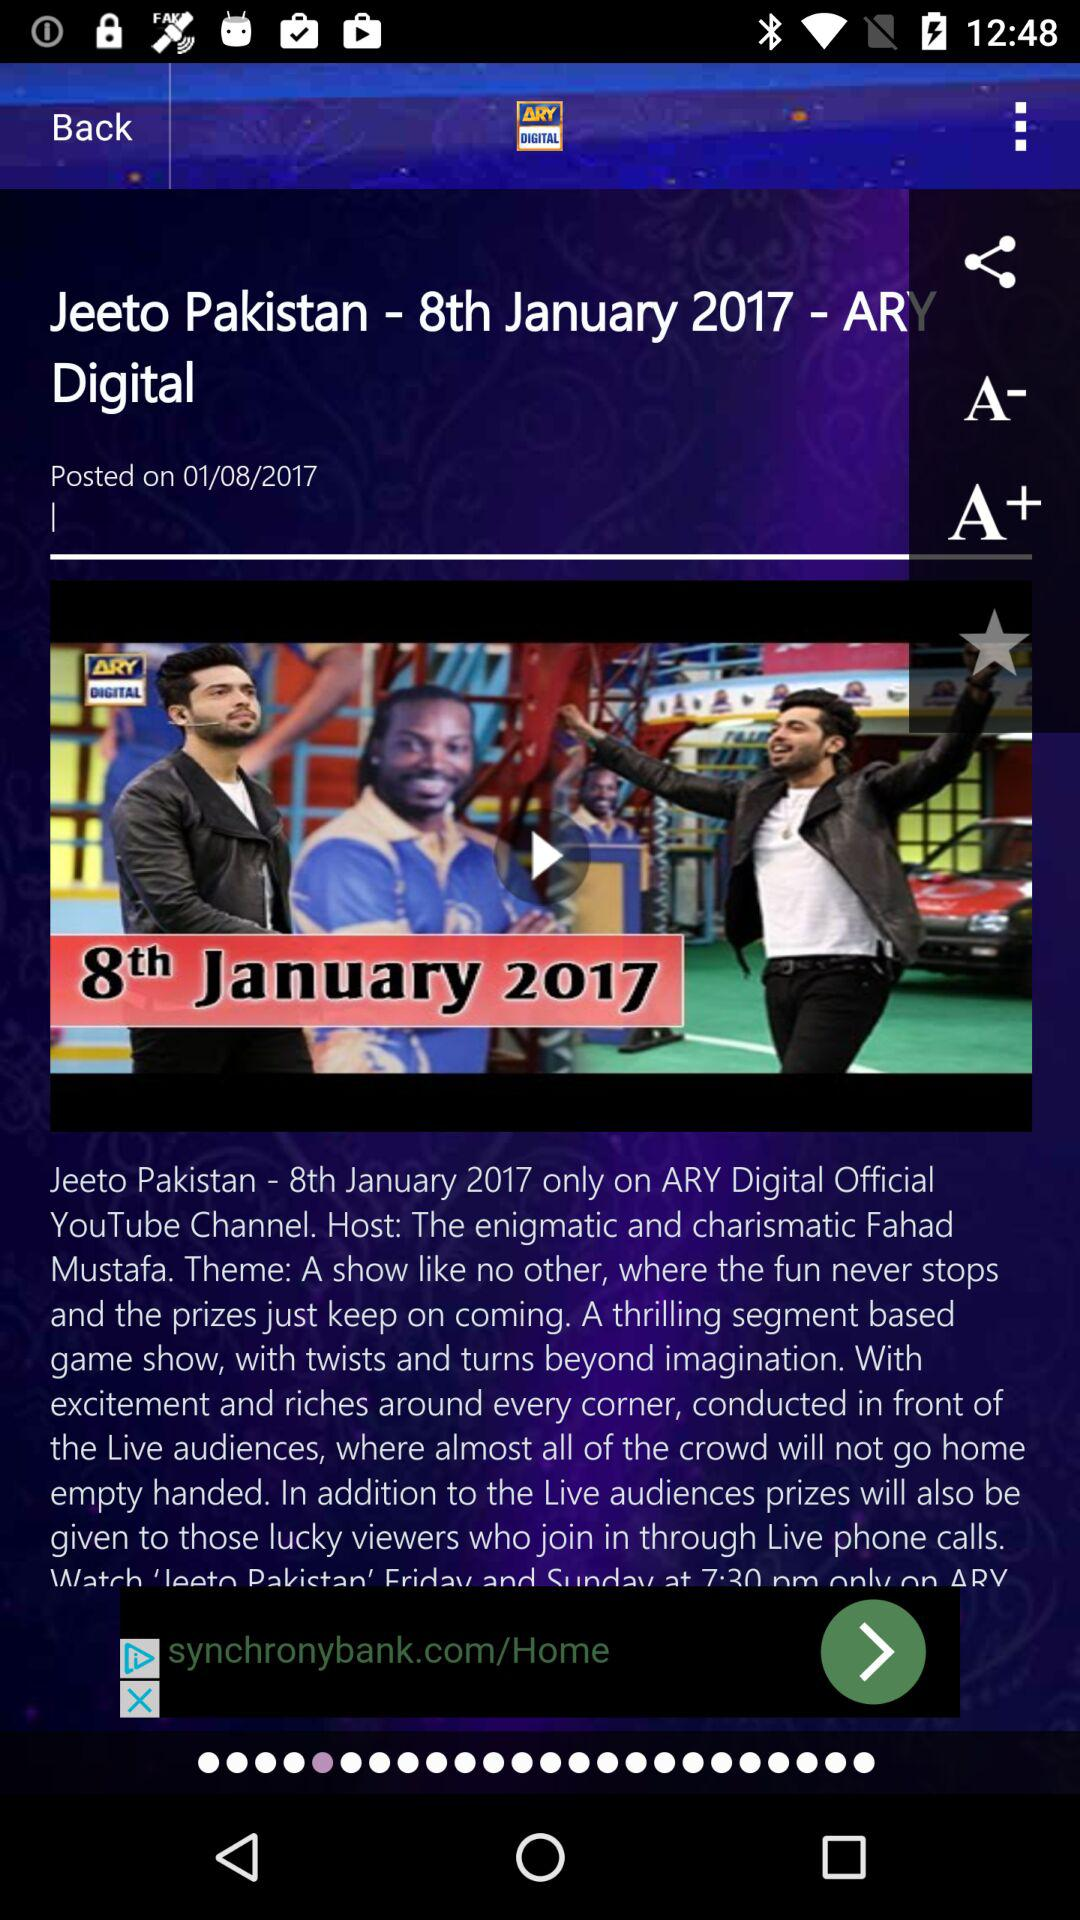What is the channel name? The channel name is "ARY DIGITAL". 